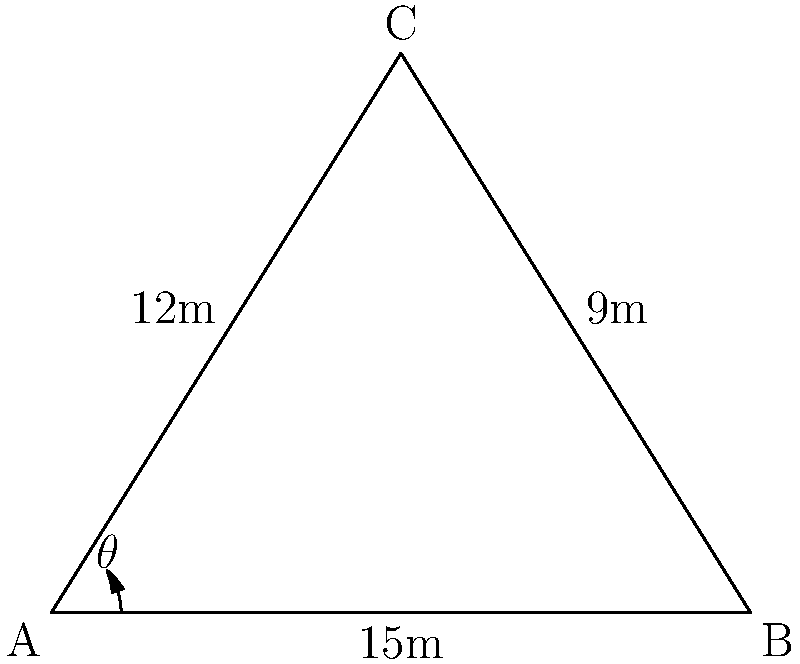At a Hong Kong movie premiere, you're setting up two spotlights to illuminate a backdrop. The spotlights are placed 15 meters apart, with the backdrop centered between them. One spotlight is 12 meters from the center of the backdrop, while the other is 9 meters away. What is the angle $\theta$ between the two spotlights, as seen from the center of the backdrop? Let's approach this step-by-step using the law of cosines:

1) Let's denote the center of the backdrop as point C, and the two spotlight positions as A and B.

2) We know:
   AC = 12 m
   BC = 9 m
   AB = 15 m

3) The law of cosines states: 
   $c^2 = a^2 + b^2 - 2ab \cos(C)$

   Where C is the angle we're looking for ($\theta$), and c is the side opposite to this angle (AB).

4) Substituting our values:
   $15^2 = 12^2 + 9^2 - 2(12)(9) \cos(\theta)$

5) Simplify:
   $225 = 144 + 81 - 216 \cos(\theta)$

6) Subtract 225 from both sides:
   $0 = 225 - 225 - 216 \cos(\theta)$
   $0 = -216 \cos(\theta)$

7) Divide both sides by -216:
   $\cos(\theta) = 0$

8) Take the inverse cosine (arccos) of both sides:
   $\theta = \arccos(0)$

9) We know that $\arccos(0) = 90°$

Therefore, the angle between the two spotlights is 90°.
Answer: 90° 